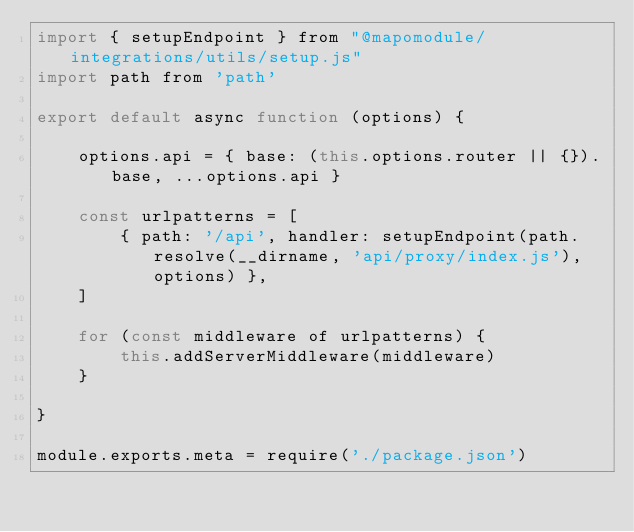Convert code to text. <code><loc_0><loc_0><loc_500><loc_500><_JavaScript_>import { setupEndpoint } from "@mapomodule/integrations/utils/setup.js"
import path from 'path'

export default async function (options) {

    options.api = { base: (this.options.router || {}).base, ...options.api }
    
    const urlpatterns = [
        { path: '/api', handler: setupEndpoint(path.resolve(__dirname, 'api/proxy/index.js'), options) },
    ]

    for (const middleware of urlpatterns) {
        this.addServerMiddleware(middleware)
    }

}

module.exports.meta = require('./package.json')
</code> 